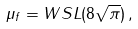<formula> <loc_0><loc_0><loc_500><loc_500>\mu _ { f } = W S L ( 8 \sqrt { \pi } ) \, ,</formula> 